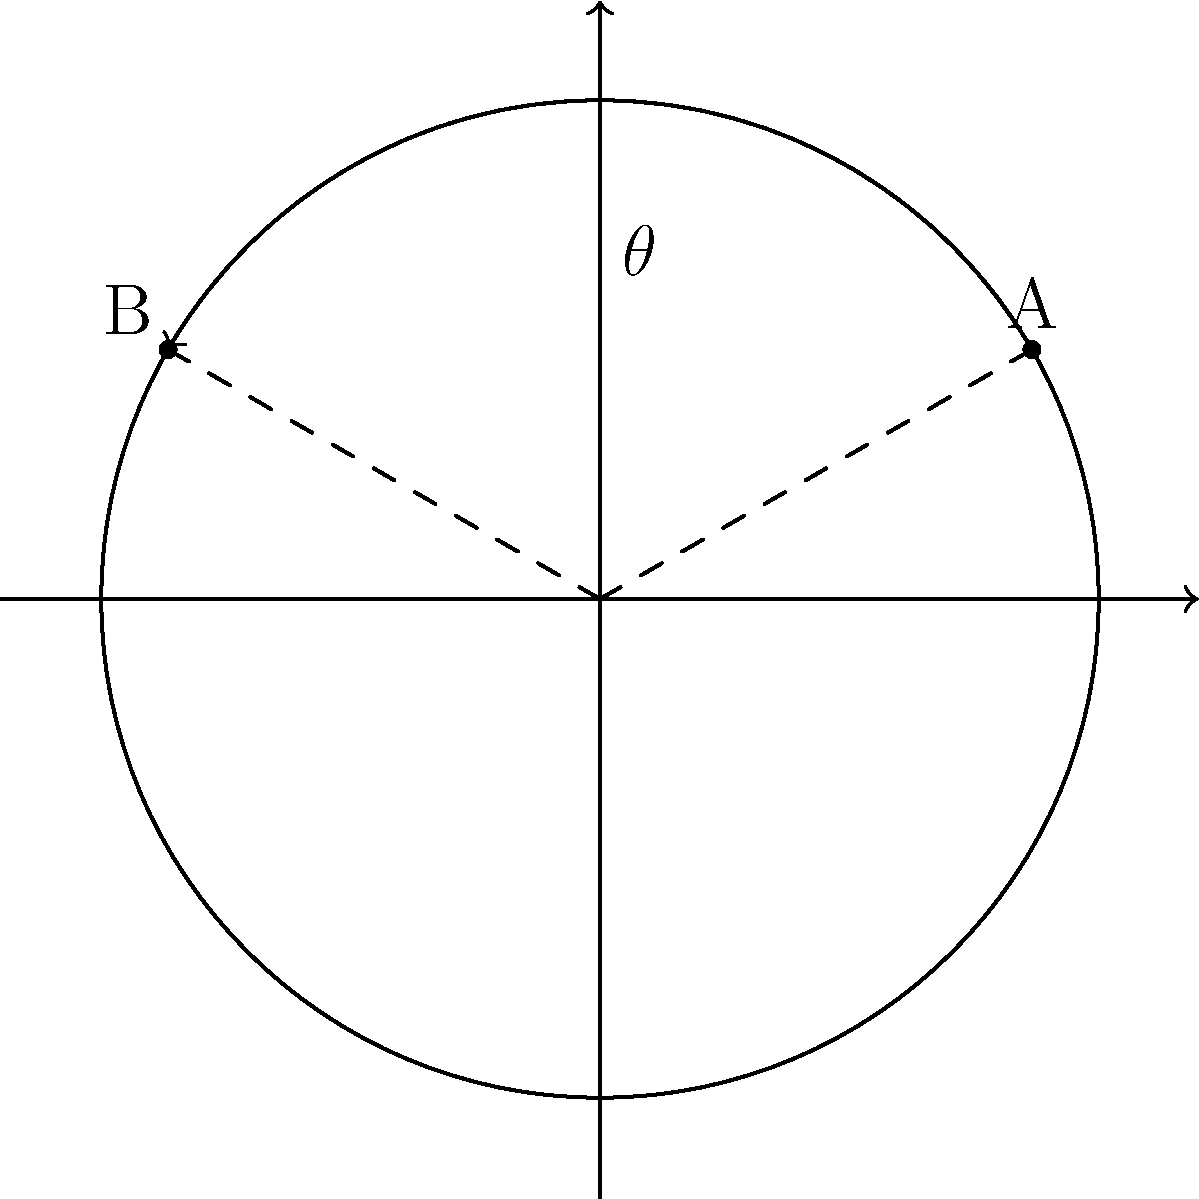Two heritage sites, A and B, are located on the outskirts of a circular town with a radius of 5 km. Site A is at coordinates $(5\cos 30°, 5\sin 30°)$ and site B is at $(5\cos 150°, 5\sin 150°)$. As the preservation regulations enforcer, you need to calculate the angular distance $\theta$ between these two sites. What is the value of $\theta$ in degrees? To find the angular distance between the two heritage sites, we can follow these steps:

1) First, recall that in polar coordinates, the angle is measured counterclockwise from the positive x-axis.

2) Site A is at $30°$ from the positive x-axis.

3) Site B is at $150°$ from the positive x-axis.

4) The angular distance $\theta$ between A and B is the absolute difference between these two angles:

   $\theta = |150° - 30°|$

5) Calculate:
   $\theta = 150° - 30° = 120°$

Therefore, the angular distance between the two heritage sites is 120°.
Answer: 120° 